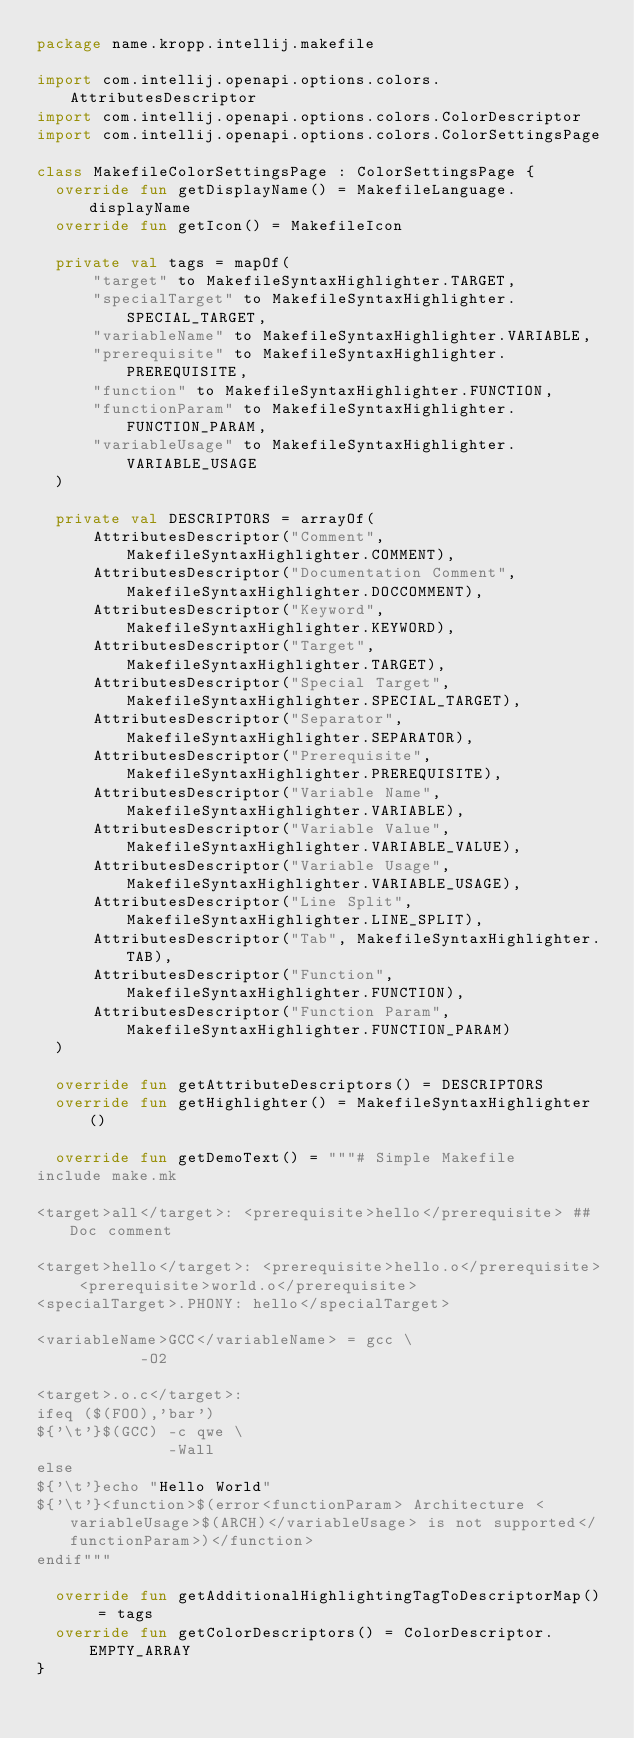<code> <loc_0><loc_0><loc_500><loc_500><_Kotlin_>package name.kropp.intellij.makefile

import com.intellij.openapi.options.colors.AttributesDescriptor
import com.intellij.openapi.options.colors.ColorDescriptor
import com.intellij.openapi.options.colors.ColorSettingsPage

class MakefileColorSettingsPage : ColorSettingsPage {
  override fun getDisplayName() = MakefileLanguage.displayName
  override fun getIcon() = MakefileIcon

  private val tags = mapOf(
      "target" to MakefileSyntaxHighlighter.TARGET,
      "specialTarget" to MakefileSyntaxHighlighter.SPECIAL_TARGET,
      "variableName" to MakefileSyntaxHighlighter.VARIABLE,
      "prerequisite" to MakefileSyntaxHighlighter.PREREQUISITE,
      "function" to MakefileSyntaxHighlighter.FUNCTION,
      "functionParam" to MakefileSyntaxHighlighter.FUNCTION_PARAM,
      "variableUsage" to MakefileSyntaxHighlighter.VARIABLE_USAGE
  )

  private val DESCRIPTORS = arrayOf(
      AttributesDescriptor("Comment", MakefileSyntaxHighlighter.COMMENT),
      AttributesDescriptor("Documentation Comment", MakefileSyntaxHighlighter.DOCCOMMENT),
      AttributesDescriptor("Keyword", MakefileSyntaxHighlighter.KEYWORD),
      AttributesDescriptor("Target", MakefileSyntaxHighlighter.TARGET),
      AttributesDescriptor("Special Target", MakefileSyntaxHighlighter.SPECIAL_TARGET),
      AttributesDescriptor("Separator", MakefileSyntaxHighlighter.SEPARATOR),
      AttributesDescriptor("Prerequisite", MakefileSyntaxHighlighter.PREREQUISITE),
      AttributesDescriptor("Variable Name", MakefileSyntaxHighlighter.VARIABLE),
      AttributesDescriptor("Variable Value", MakefileSyntaxHighlighter.VARIABLE_VALUE),
      AttributesDescriptor("Variable Usage", MakefileSyntaxHighlighter.VARIABLE_USAGE),
      AttributesDescriptor("Line Split", MakefileSyntaxHighlighter.LINE_SPLIT),
      AttributesDescriptor("Tab", MakefileSyntaxHighlighter.TAB),
      AttributesDescriptor("Function", MakefileSyntaxHighlighter.FUNCTION),
      AttributesDescriptor("Function Param", MakefileSyntaxHighlighter.FUNCTION_PARAM)
  )

  override fun getAttributeDescriptors() = DESCRIPTORS
  override fun getHighlighter() = MakefileSyntaxHighlighter()

  override fun getDemoText() = """# Simple Makefile
include make.mk

<target>all</target>: <prerequisite>hello</prerequisite> ## Doc comment

<target>hello</target>: <prerequisite>hello.o</prerequisite> <prerequisite>world.o</prerequisite>
<specialTarget>.PHONY: hello</specialTarget>

<variableName>GCC</variableName> = gcc \
           -O2

<target>.o.c</target>:
ifeq ($(FOO),'bar')
${'\t'}$(GCC) -c qwe \
              -Wall
else
${'\t'}echo "Hello World"
${'\t'}<function>$(error<functionParam> Architecture <variableUsage>$(ARCH)</variableUsage> is not supported</functionParam>)</function>
endif"""

  override fun getAdditionalHighlightingTagToDescriptorMap() = tags
  override fun getColorDescriptors() = ColorDescriptor.EMPTY_ARRAY
}</code> 